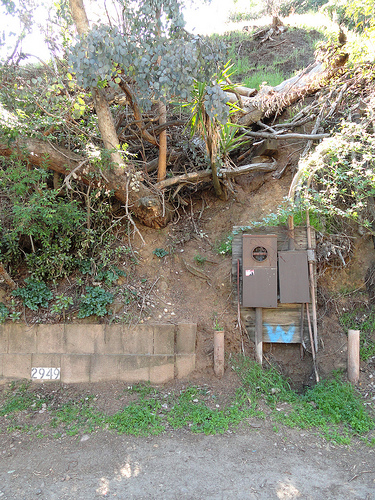<image>
Can you confirm if the address is under the tree? Yes. The address is positioned underneath the tree, with the tree above it in the vertical space. 